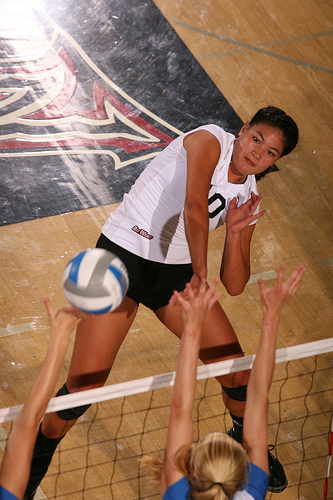<image>
Can you confirm if the girl is on the ball? No. The girl is not positioned on the ball. They may be near each other, but the girl is not supported by or resting on top of the ball. 